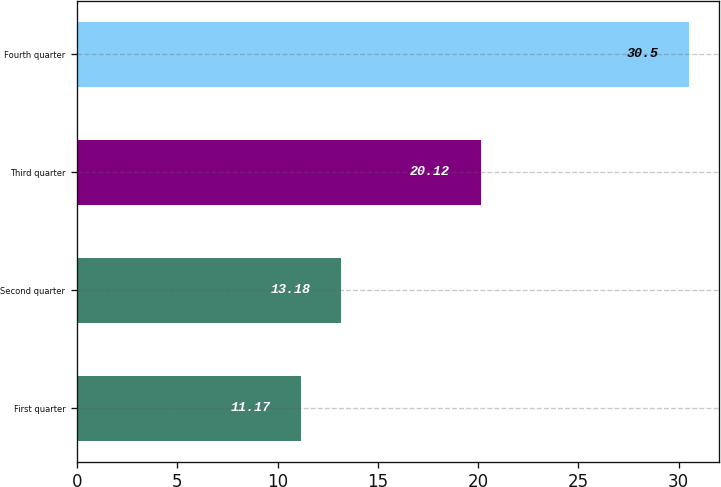Convert chart. <chart><loc_0><loc_0><loc_500><loc_500><bar_chart><fcel>First quarter<fcel>Second quarter<fcel>Third quarter<fcel>Fourth quarter<nl><fcel>11.17<fcel>13.18<fcel>20.12<fcel>30.5<nl></chart> 